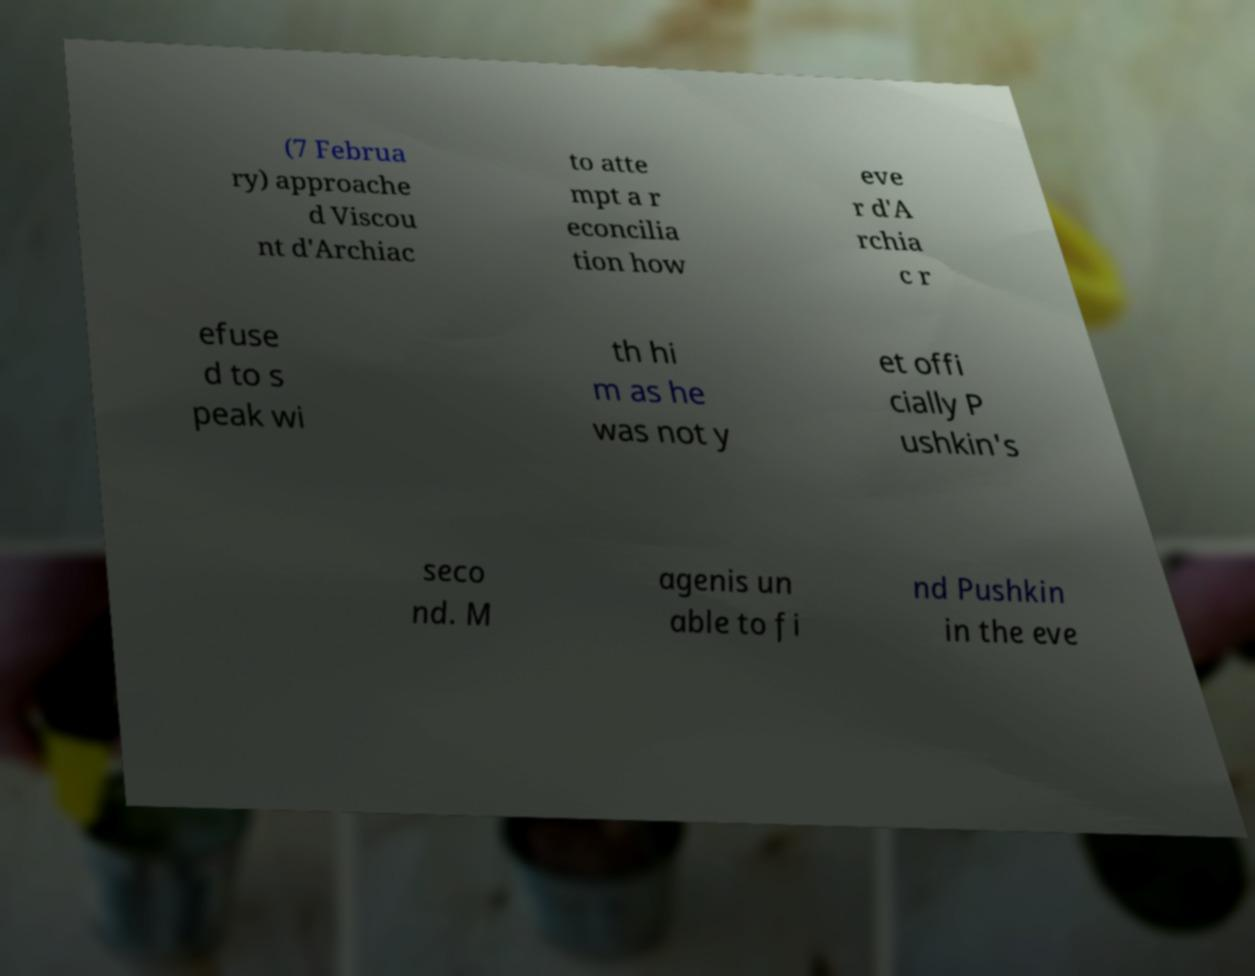What messages or text are displayed in this image? I need them in a readable, typed format. (7 Februa ry) approache d Viscou nt d'Archiac to atte mpt a r econcilia tion how eve r d'A rchia c r efuse d to s peak wi th hi m as he was not y et offi cially P ushkin's seco nd. M agenis un able to fi nd Pushkin in the eve 